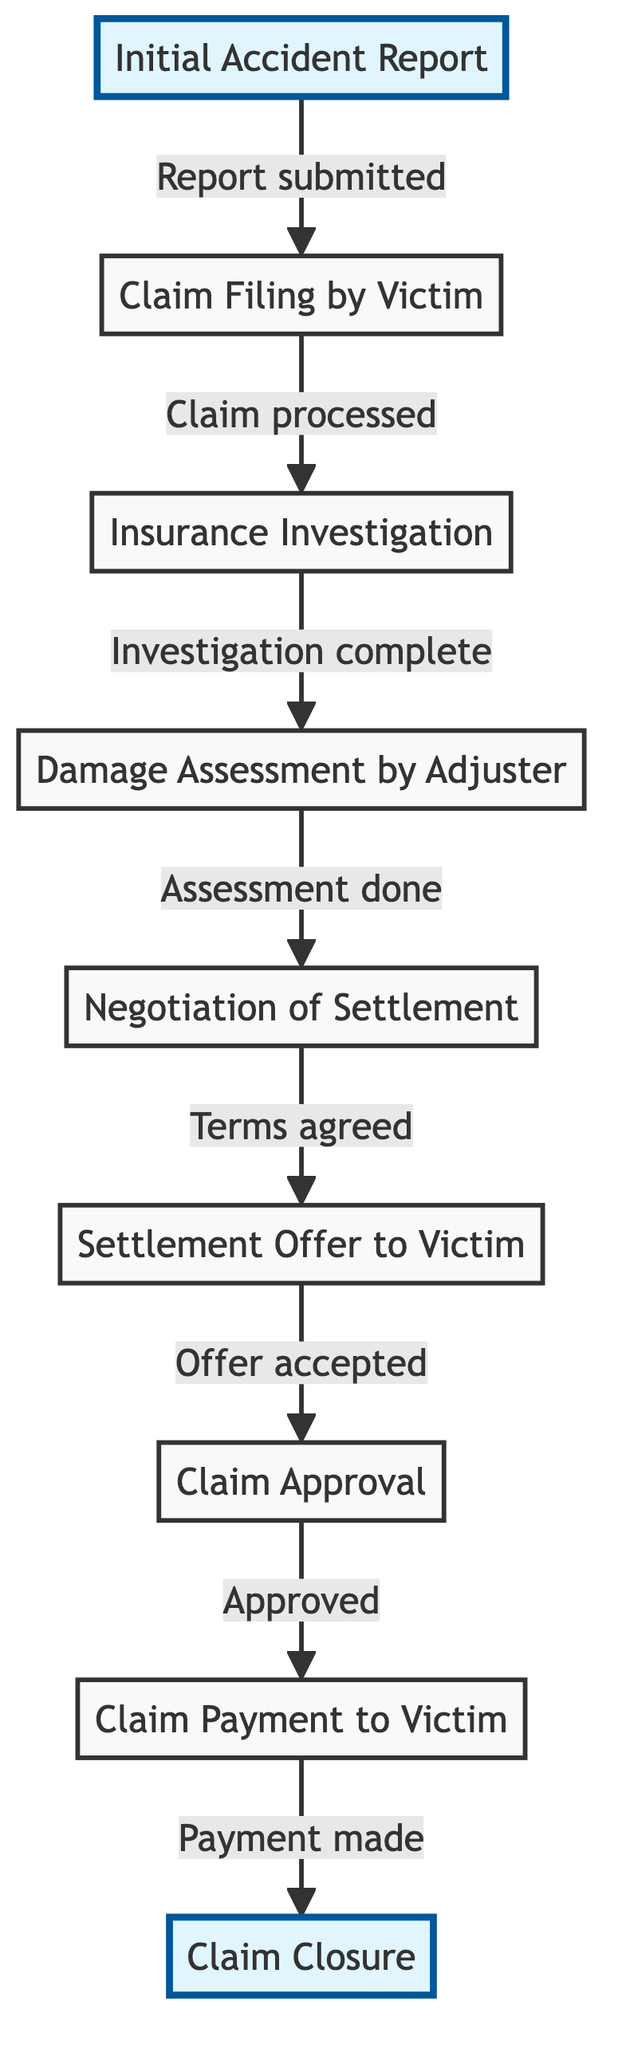What is the first step in the claim settlement process? The first step in the claim settlement process, as represented by the directed graph, is the "Initial Accident Report." This is where the process begins, indicating that the victim reports the accident initially.
Answer: Initial Accident Report How many nodes are present in the diagram? To find the number of nodes, we can count each unique step in the process. The diagram has 9 distinct nodes: Initial Accident Report, Claim Filing by Victim, Insurance Investigation, Damage Assessment by Adjuster, Negotiation of Settlement, Settlement Offer to Victim, Claim Approval, Claim Payment to Victim, Claim Closure.
Answer: 9 What comes after "Claim Filing by Victim"? The directed graph indicates the flow of the process, showing that after "Claim Filing by Victim," the next step is "Insurance Investigation." This demonstrates the sequence of events in the claim settlement process.
Answer: Insurance Investigation Which step involves the adjuster? The "Damage Assessment by Adjuster" is the step that directly involves the adjuster. This step indicates the adjuster's role in evaluating the damages related to the claim after the investigation is complete.
Answer: Damage Assessment by Adjuster What is the last step before claim closure? According to the flowchart, the last step before "Claim Closure" is "Claim Payment to Victim." This indicates that payment is made to the victim before the claim is finally closed.
Answer: Claim Payment to Victim How many edges are in the diagram? To determine the number of edges, we count each directed connection between the nodes. The diagram has 8 edges that indicate relationships between different steps in the claim process.
Answer: 8 What is the relationship between "Negotiation of Settlement" and "Settlement Offer to Victim"? The directed graph shows that "Negotiation of Settlement" leads to "Settlement Offer to Victim." The relationship indicates that, after negotiations are conducted, an offer is made to the victim as the next step in the process.
Answer: Settlement Offer to Victim Which node has a direct connection to "Claim Approval"? The node "Settlement Offer to Victim" has a direct connection to "Claim Approval." This shows that an accepted settlement offer leads directly to the claim's approval by the insurance company.
Answer: Settlement Offer to Victim 